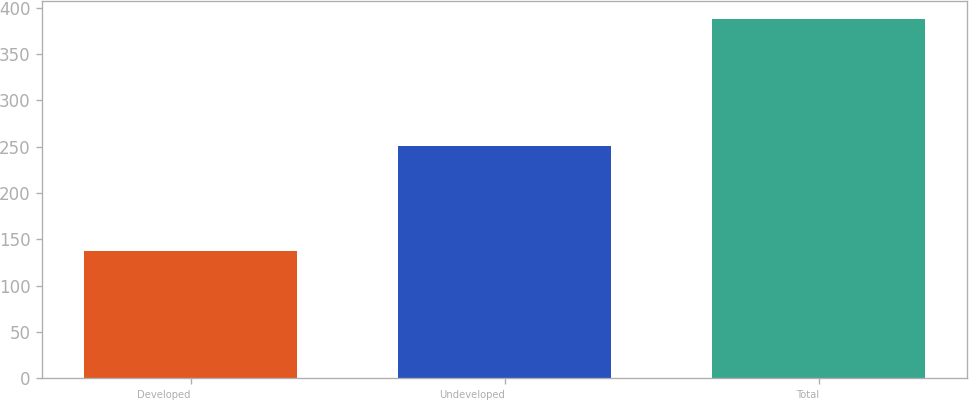Convert chart to OTSL. <chart><loc_0><loc_0><loc_500><loc_500><bar_chart><fcel>Developed<fcel>Undeveloped<fcel>Total<nl><fcel>137<fcel>251<fcel>388<nl></chart> 